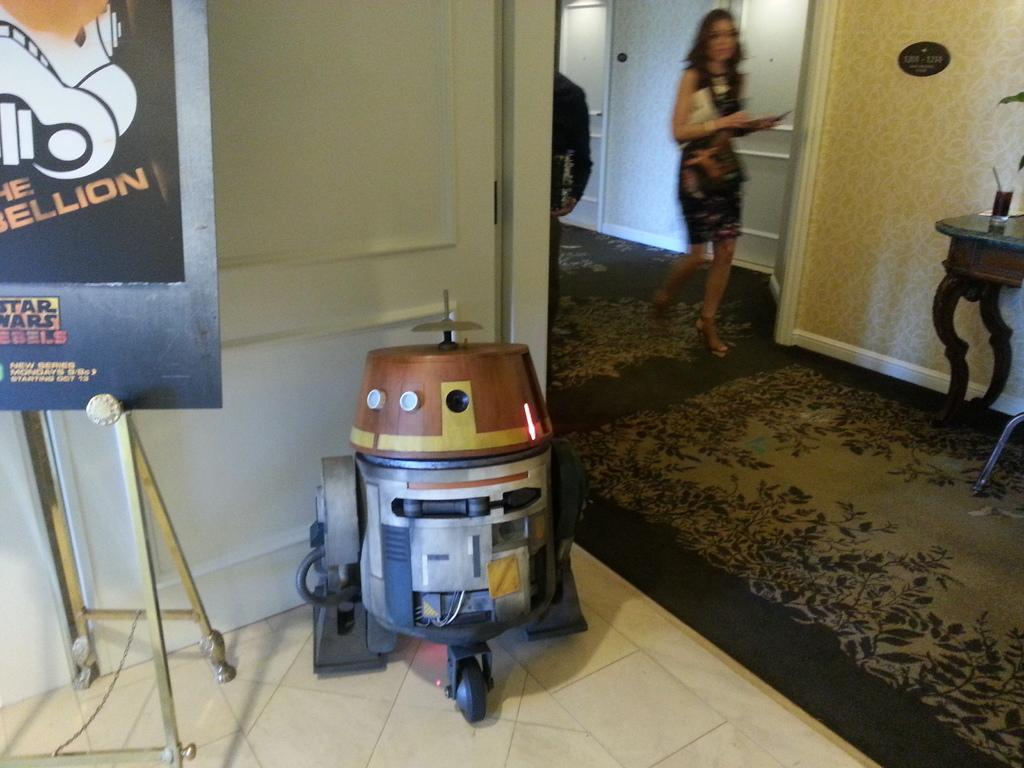<image>
Provide a brief description of the given image. A model of a star wars character next to a Star Wars Rebels sign 